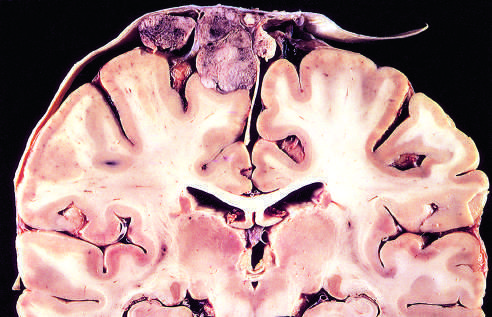what is attached to the dura with compression of underlying brain?
Answer the question using a single word or phrase. Parasagittal multilobular meningioma 